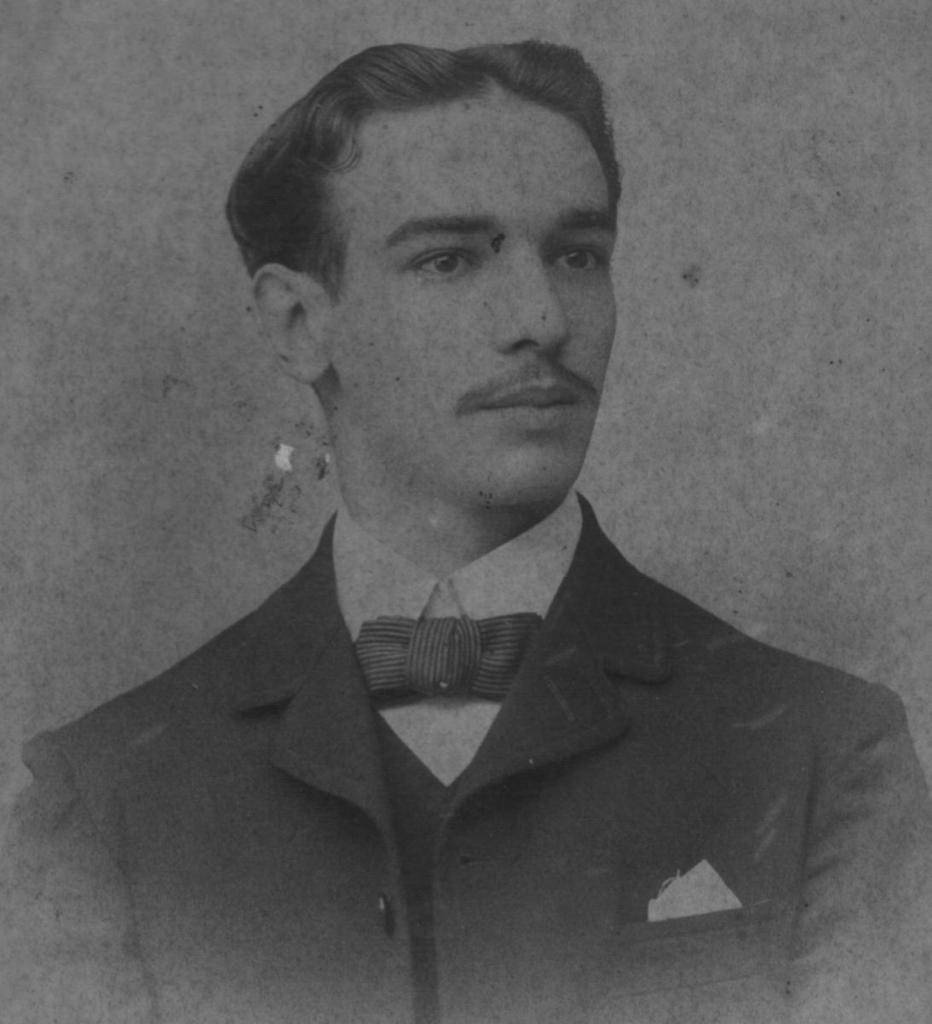Can you describe this image briefly? This is a black and white image where I can see a photograph of a person wearing blazer, shirt and bow. 